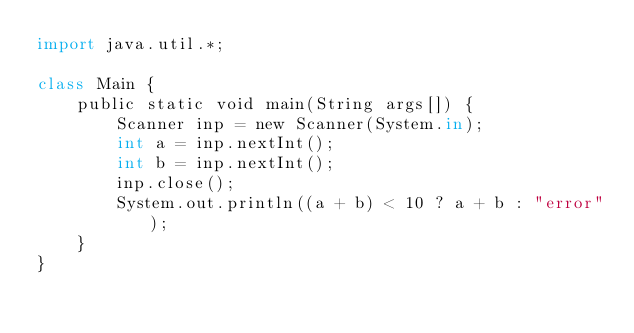<code> <loc_0><loc_0><loc_500><loc_500><_Python_>import java.util.*;

class Main {
    public static void main(String args[]) {
        Scanner inp = new Scanner(System.in);
        int a = inp.nextInt();
        int b = inp.nextInt();
        inp.close();
        System.out.println((a + b) < 10 ? a + b : "error");
    }
}</code> 